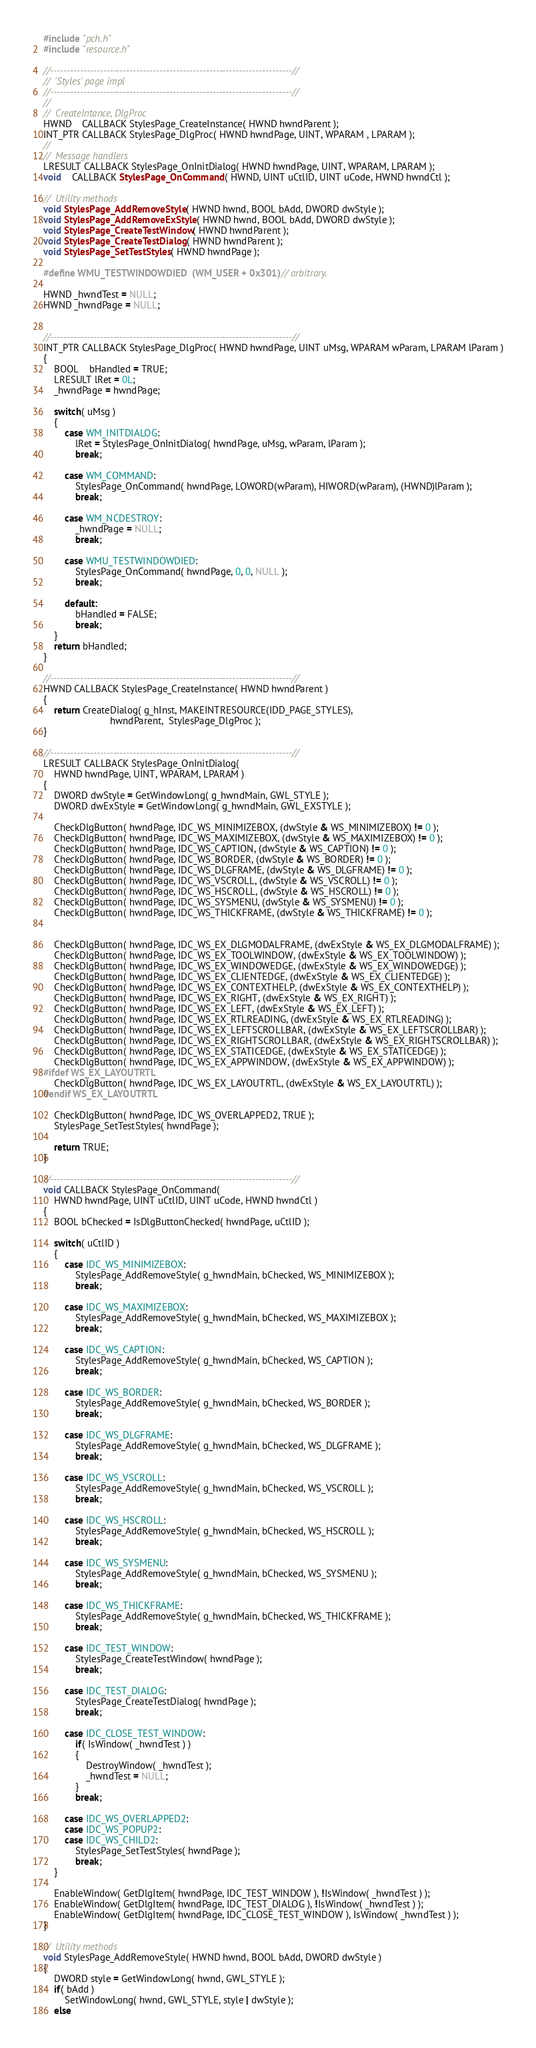<code> <loc_0><loc_0><loc_500><loc_500><_C++_>#include "pch.h"
#include "resource.h"

//-------------------------------------------------------------------------//
//  'Styles' page impl
//-------------------------------------------------------------------------//
//
//  CreateIntance, DlgProc
HWND    CALLBACK StylesPage_CreateInstance( HWND hwndParent );
INT_PTR CALLBACK StylesPage_DlgProc( HWND hwndPage, UINT, WPARAM , LPARAM );
//
//  Message handlers
LRESULT CALLBACK StylesPage_OnInitDialog( HWND hwndPage, UINT, WPARAM, LPARAM );
void    CALLBACK StylesPage_OnCommand( HWND, UINT uCtlID, UINT uCode, HWND hwndCtl );

//  Utility methods
void StylesPage_AddRemoveStyle( HWND hwnd, BOOL bAdd, DWORD dwStyle );
void StylesPage_AddRemoveExStyle( HWND hwnd, BOOL bAdd, DWORD dwStyle );
void StylesPage_CreateTestWindow( HWND hwndParent );
void StylesPage_CreateTestDialog( HWND hwndParent );
void StylesPage_SetTestStyles( HWND hwndPage );

#define WMU_TESTWINDOWDIED  (WM_USER + 0x301) // arbitrary.

HWND _hwndTest = NULL;
HWND _hwndPage = NULL;


//-------------------------------------------------------------------------//
INT_PTR CALLBACK StylesPage_DlgProc( HWND hwndPage, UINT uMsg, WPARAM wParam, LPARAM lParam )
{
    BOOL    bHandled = TRUE;
    LRESULT lRet = 0L;
    _hwndPage = hwndPage;

    switch( uMsg )
    {
        case WM_INITDIALOG:
            lRet = StylesPage_OnInitDialog( hwndPage, uMsg, wParam, lParam );
            break;

        case WM_COMMAND:
            StylesPage_OnCommand( hwndPage, LOWORD(wParam), HIWORD(wParam), (HWND)lParam );
            break;

        case WM_NCDESTROY:
            _hwndPage = NULL;
            break;

        case WMU_TESTWINDOWDIED:
            StylesPage_OnCommand( hwndPage, 0, 0, NULL );
            break;

        default: 
            bHandled = FALSE;
            break;
    }
    return bHandled;
}

//-------------------------------------------------------------------------//
HWND CALLBACK StylesPage_CreateInstance( HWND hwndParent )
{
    return CreateDialog( g_hInst, MAKEINTRESOURCE(IDD_PAGE_STYLES),
                         hwndParent,  StylesPage_DlgProc );
}

//-------------------------------------------------------------------------//
LRESULT CALLBACK StylesPage_OnInitDialog(
    HWND hwndPage, UINT, WPARAM, LPARAM )
{
    DWORD dwStyle = GetWindowLong( g_hwndMain, GWL_STYLE );
    DWORD dwExStyle = GetWindowLong( g_hwndMain, GWL_EXSTYLE );

    CheckDlgButton( hwndPage, IDC_WS_MINIMIZEBOX, (dwStyle & WS_MINIMIZEBOX) != 0 );
    CheckDlgButton( hwndPage, IDC_WS_MAXIMIZEBOX, (dwStyle & WS_MAXIMIZEBOX) != 0 );
    CheckDlgButton( hwndPage, IDC_WS_CAPTION, (dwStyle & WS_CAPTION) != 0 );
    CheckDlgButton( hwndPage, IDC_WS_BORDER, (dwStyle & WS_BORDER) != 0 );
    CheckDlgButton( hwndPage, IDC_WS_DLGFRAME, (dwStyle & WS_DLGFRAME) != 0 );
    CheckDlgButton( hwndPage, IDC_WS_VSCROLL, (dwStyle & WS_VSCROLL) != 0 );
    CheckDlgButton( hwndPage, IDC_WS_HSCROLL, (dwStyle & WS_HSCROLL) != 0 );
    CheckDlgButton( hwndPage, IDC_WS_SYSMENU, (dwStyle & WS_SYSMENU) != 0 );
    CheckDlgButton( hwndPage, IDC_WS_THICKFRAME, (dwStyle & WS_THICKFRAME) != 0 );


    CheckDlgButton( hwndPage, IDC_WS_EX_DLGMODALFRAME, (dwExStyle & WS_EX_DLGMODALFRAME) );
    CheckDlgButton( hwndPage, IDC_WS_EX_TOOLWINDOW, (dwExStyle & WS_EX_TOOLWINDOW) );
    CheckDlgButton( hwndPage, IDC_WS_EX_WINDOWEDGE, (dwExStyle & WS_EX_WINDOWEDGE) );
    CheckDlgButton( hwndPage, IDC_WS_EX_CLIENTEDGE, (dwExStyle & WS_EX_CLIENTEDGE) );
    CheckDlgButton( hwndPage, IDC_WS_EX_CONTEXTHELP, (dwExStyle & WS_EX_CONTEXTHELP) );
    CheckDlgButton( hwndPage, IDC_WS_EX_RIGHT, (dwExStyle & WS_EX_RIGHT) );
    CheckDlgButton( hwndPage, IDC_WS_EX_LEFT, (dwExStyle & WS_EX_LEFT) );
    CheckDlgButton( hwndPage, IDC_WS_EX_RTLREADING, (dwExStyle & WS_EX_RTLREADING) );
    CheckDlgButton( hwndPage, IDC_WS_EX_LEFTSCROLLBAR, (dwExStyle & WS_EX_LEFTSCROLLBAR) );
    CheckDlgButton( hwndPage, IDC_WS_EX_RIGHTSCROLLBAR, (dwExStyle & WS_EX_RIGHTSCROLLBAR) );
    CheckDlgButton( hwndPage, IDC_WS_EX_STATICEDGE, (dwExStyle & WS_EX_STATICEDGE) );
    CheckDlgButton( hwndPage, IDC_WS_EX_APPWINDOW, (dwExStyle & WS_EX_APPWINDOW) );
#ifdef WS_EX_LAYOUTRTL
    CheckDlgButton( hwndPage, IDC_WS_EX_LAYOUTRTL, (dwExStyle & WS_EX_LAYOUTRTL) );
#endif WS_EX_LAYOUTRTL

    CheckDlgButton( hwndPage, IDC_WS_OVERLAPPED2, TRUE );
    StylesPage_SetTestStyles( hwndPage );

    return TRUE;
}

//-------------------------------------------------------------------------//
void CALLBACK StylesPage_OnCommand( 
    HWND hwndPage, UINT uCtlID, UINT uCode, HWND hwndCtl )
{
    BOOL bChecked = IsDlgButtonChecked( hwndPage, uCtlID );

    switch( uCtlID )
    {
        case IDC_WS_MINIMIZEBOX:
            StylesPage_AddRemoveStyle( g_hwndMain, bChecked, WS_MINIMIZEBOX );
            break;

        case IDC_WS_MAXIMIZEBOX:
            StylesPage_AddRemoveStyle( g_hwndMain, bChecked, WS_MAXIMIZEBOX );
            break;

        case IDC_WS_CAPTION:
            StylesPage_AddRemoveStyle( g_hwndMain, bChecked, WS_CAPTION );
            break;

        case IDC_WS_BORDER:
            StylesPage_AddRemoveStyle( g_hwndMain, bChecked, WS_BORDER );
            break;

        case IDC_WS_DLGFRAME:
            StylesPage_AddRemoveStyle( g_hwndMain, bChecked, WS_DLGFRAME );
            break;

        case IDC_WS_VSCROLL:
            StylesPage_AddRemoveStyle( g_hwndMain, bChecked, WS_VSCROLL );
            break;

        case IDC_WS_HSCROLL:
            StylesPage_AddRemoveStyle( g_hwndMain, bChecked, WS_HSCROLL );
            break;

        case IDC_WS_SYSMENU:
            StylesPage_AddRemoveStyle( g_hwndMain, bChecked, WS_SYSMENU );
            break;

        case IDC_WS_THICKFRAME:
            StylesPage_AddRemoveStyle( g_hwndMain, bChecked, WS_THICKFRAME );
            break;

        case IDC_TEST_WINDOW:
            StylesPage_CreateTestWindow( hwndPage );
            break;

        case IDC_TEST_DIALOG:
            StylesPage_CreateTestDialog( hwndPage );
            break;

        case IDC_CLOSE_TEST_WINDOW:
            if( IsWindow( _hwndTest ) )
            {
                DestroyWindow( _hwndTest );
                _hwndTest = NULL;
            }
            break;

        case IDC_WS_OVERLAPPED2:
        case IDC_WS_POPUP2:
        case IDC_WS_CHILD2:
            StylesPage_SetTestStyles( hwndPage );
            break;
    }

    EnableWindow( GetDlgItem( hwndPage, IDC_TEST_WINDOW ), !IsWindow( _hwndTest ) );
    EnableWindow( GetDlgItem( hwndPage, IDC_TEST_DIALOG ), !IsWindow( _hwndTest ) );
    EnableWindow( GetDlgItem( hwndPage, IDC_CLOSE_TEST_WINDOW ), IsWindow( _hwndTest ) );
}

//  Utility methods
void StylesPage_AddRemoveStyle( HWND hwnd, BOOL bAdd, DWORD dwStyle )
{
    DWORD style = GetWindowLong( hwnd, GWL_STYLE );
    if( bAdd )
        SetWindowLong( hwnd, GWL_STYLE, style | dwStyle );
    else</code> 